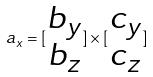<formula> <loc_0><loc_0><loc_500><loc_500>a _ { x } = [ \begin{matrix} b _ { y } \\ b _ { z } \end{matrix} ] \times [ \begin{matrix} c _ { y } \\ c _ { z } \end{matrix} ]</formula> 